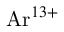<formula> <loc_0><loc_0><loc_500><loc_500>{ A r } ^ { 1 3 + }</formula> 